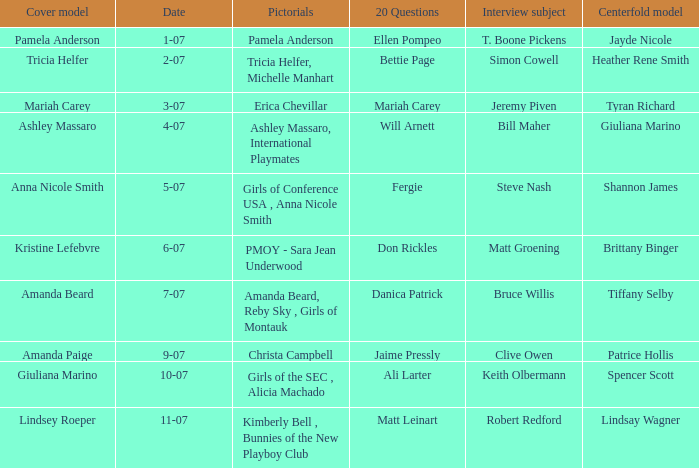Who was the centerfold model in the issue where Fergie answered the "20 questions"? Shannon James. 